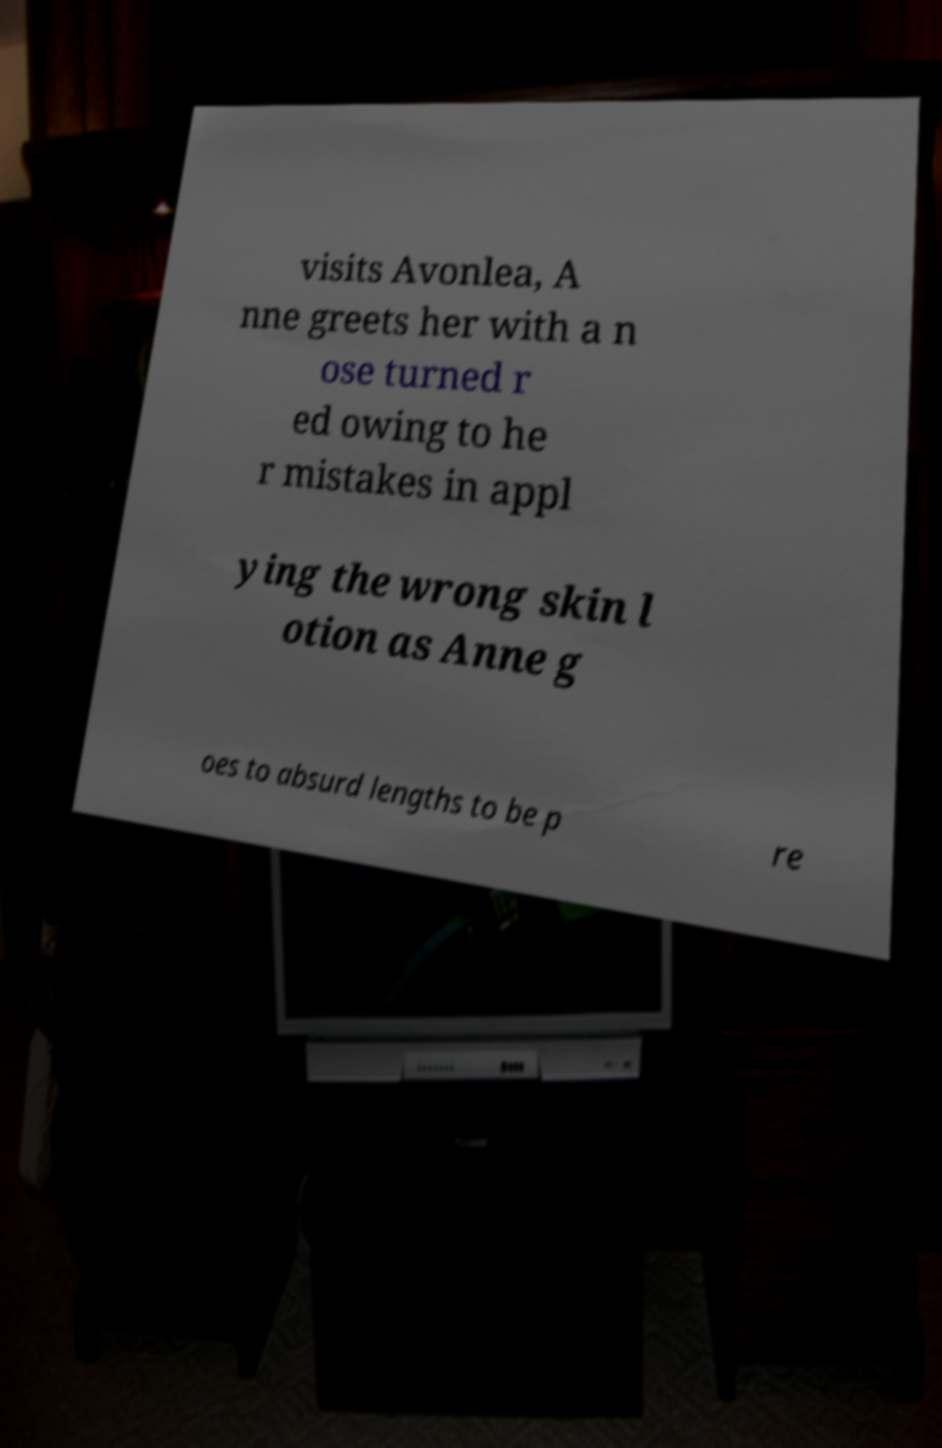Could you assist in decoding the text presented in this image and type it out clearly? visits Avonlea, A nne greets her with a n ose turned r ed owing to he r mistakes in appl ying the wrong skin l otion as Anne g oes to absurd lengths to be p re 